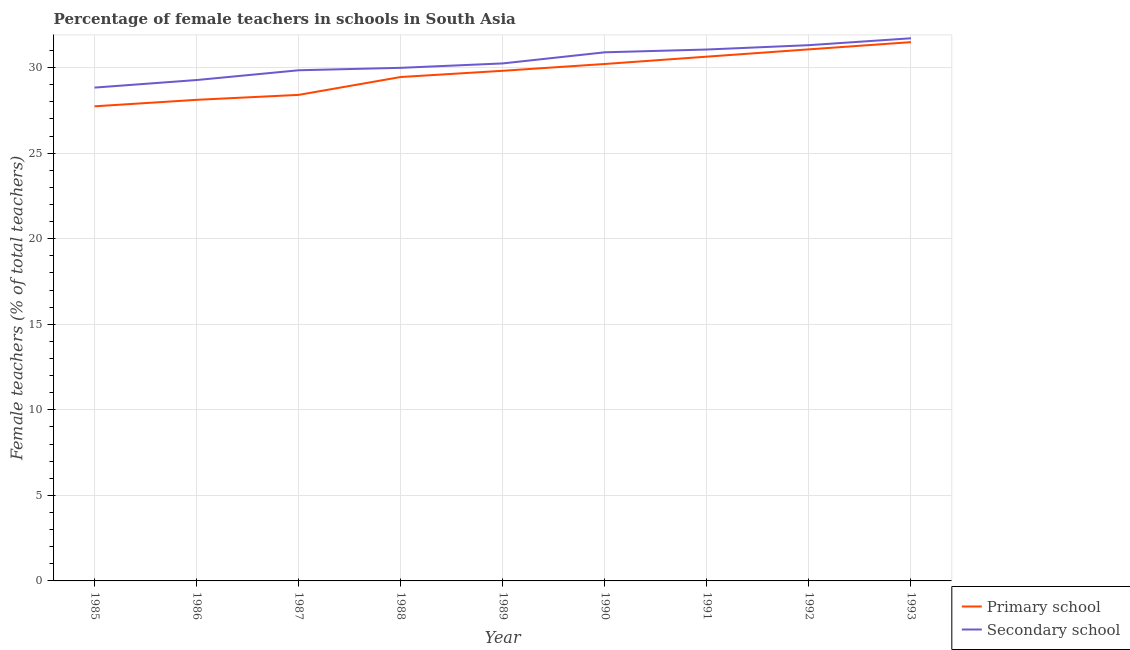How many different coloured lines are there?
Provide a short and direct response. 2. Is the number of lines equal to the number of legend labels?
Provide a short and direct response. Yes. What is the percentage of female teachers in secondary schools in 1990?
Your response must be concise. 30.89. Across all years, what is the maximum percentage of female teachers in primary schools?
Keep it short and to the point. 31.49. Across all years, what is the minimum percentage of female teachers in secondary schools?
Offer a terse response. 28.83. In which year was the percentage of female teachers in secondary schools maximum?
Provide a short and direct response. 1993. What is the total percentage of female teachers in secondary schools in the graph?
Give a very brief answer. 273.14. What is the difference between the percentage of female teachers in secondary schools in 1985 and that in 1992?
Provide a succinct answer. -2.48. What is the difference between the percentage of female teachers in secondary schools in 1985 and the percentage of female teachers in primary schools in 1986?
Make the answer very short. 0.71. What is the average percentage of female teachers in primary schools per year?
Provide a short and direct response. 29.66. In the year 1991, what is the difference between the percentage of female teachers in primary schools and percentage of female teachers in secondary schools?
Offer a very short reply. -0.42. What is the ratio of the percentage of female teachers in primary schools in 1987 to that in 1993?
Provide a short and direct response. 0.9. Is the difference between the percentage of female teachers in secondary schools in 1987 and 1991 greater than the difference between the percentage of female teachers in primary schools in 1987 and 1991?
Provide a short and direct response. Yes. What is the difference between the highest and the second highest percentage of female teachers in secondary schools?
Give a very brief answer. 0.4. What is the difference between the highest and the lowest percentage of female teachers in secondary schools?
Offer a terse response. 2.88. Does the percentage of female teachers in primary schools monotonically increase over the years?
Your answer should be very brief. Yes. Is the percentage of female teachers in secondary schools strictly less than the percentage of female teachers in primary schools over the years?
Your response must be concise. No. How many years are there in the graph?
Ensure brevity in your answer.  9. What is the difference between two consecutive major ticks on the Y-axis?
Give a very brief answer. 5. Are the values on the major ticks of Y-axis written in scientific E-notation?
Offer a very short reply. No. Where does the legend appear in the graph?
Provide a succinct answer. Bottom right. How many legend labels are there?
Ensure brevity in your answer.  2. How are the legend labels stacked?
Your response must be concise. Vertical. What is the title of the graph?
Provide a succinct answer. Percentage of female teachers in schools in South Asia. What is the label or title of the Y-axis?
Offer a terse response. Female teachers (% of total teachers). What is the Female teachers (% of total teachers) in Primary school in 1985?
Ensure brevity in your answer.  27.74. What is the Female teachers (% of total teachers) in Secondary school in 1985?
Give a very brief answer. 28.83. What is the Female teachers (% of total teachers) in Primary school in 1986?
Keep it short and to the point. 28.11. What is the Female teachers (% of total teachers) of Secondary school in 1986?
Make the answer very short. 29.27. What is the Female teachers (% of total teachers) of Primary school in 1987?
Offer a very short reply. 28.4. What is the Female teachers (% of total teachers) of Secondary school in 1987?
Your answer should be compact. 29.84. What is the Female teachers (% of total teachers) of Primary school in 1988?
Give a very brief answer. 29.45. What is the Female teachers (% of total teachers) in Secondary school in 1988?
Offer a terse response. 29.99. What is the Female teachers (% of total teachers) of Primary school in 1989?
Offer a terse response. 29.81. What is the Female teachers (% of total teachers) of Secondary school in 1989?
Ensure brevity in your answer.  30.24. What is the Female teachers (% of total teachers) of Primary school in 1990?
Offer a terse response. 30.21. What is the Female teachers (% of total teachers) of Secondary school in 1990?
Your answer should be compact. 30.89. What is the Female teachers (% of total teachers) of Primary school in 1991?
Provide a short and direct response. 30.64. What is the Female teachers (% of total teachers) in Secondary school in 1991?
Offer a terse response. 31.06. What is the Female teachers (% of total teachers) of Primary school in 1992?
Your response must be concise. 31.06. What is the Female teachers (% of total teachers) of Secondary school in 1992?
Offer a very short reply. 31.31. What is the Female teachers (% of total teachers) in Primary school in 1993?
Make the answer very short. 31.49. What is the Female teachers (% of total teachers) of Secondary school in 1993?
Offer a terse response. 31.71. Across all years, what is the maximum Female teachers (% of total teachers) in Primary school?
Your answer should be very brief. 31.49. Across all years, what is the maximum Female teachers (% of total teachers) of Secondary school?
Give a very brief answer. 31.71. Across all years, what is the minimum Female teachers (% of total teachers) of Primary school?
Ensure brevity in your answer.  27.74. Across all years, what is the minimum Female teachers (% of total teachers) of Secondary school?
Give a very brief answer. 28.83. What is the total Female teachers (% of total teachers) of Primary school in the graph?
Your answer should be compact. 266.91. What is the total Female teachers (% of total teachers) in Secondary school in the graph?
Your answer should be compact. 273.14. What is the difference between the Female teachers (% of total teachers) of Primary school in 1985 and that in 1986?
Keep it short and to the point. -0.38. What is the difference between the Female teachers (% of total teachers) in Secondary school in 1985 and that in 1986?
Ensure brevity in your answer.  -0.44. What is the difference between the Female teachers (% of total teachers) of Primary school in 1985 and that in 1987?
Your answer should be compact. -0.67. What is the difference between the Female teachers (% of total teachers) in Secondary school in 1985 and that in 1987?
Provide a succinct answer. -1.01. What is the difference between the Female teachers (% of total teachers) of Primary school in 1985 and that in 1988?
Ensure brevity in your answer.  -1.71. What is the difference between the Female teachers (% of total teachers) in Secondary school in 1985 and that in 1988?
Give a very brief answer. -1.16. What is the difference between the Female teachers (% of total teachers) in Primary school in 1985 and that in 1989?
Make the answer very short. -2.08. What is the difference between the Female teachers (% of total teachers) in Secondary school in 1985 and that in 1989?
Ensure brevity in your answer.  -1.41. What is the difference between the Female teachers (% of total teachers) of Primary school in 1985 and that in 1990?
Ensure brevity in your answer.  -2.47. What is the difference between the Female teachers (% of total teachers) in Secondary school in 1985 and that in 1990?
Offer a very short reply. -2.06. What is the difference between the Female teachers (% of total teachers) in Primary school in 1985 and that in 1991?
Provide a short and direct response. -2.9. What is the difference between the Female teachers (% of total teachers) in Secondary school in 1985 and that in 1991?
Make the answer very short. -2.23. What is the difference between the Female teachers (% of total teachers) in Primary school in 1985 and that in 1992?
Give a very brief answer. -3.33. What is the difference between the Female teachers (% of total teachers) in Secondary school in 1985 and that in 1992?
Ensure brevity in your answer.  -2.48. What is the difference between the Female teachers (% of total teachers) of Primary school in 1985 and that in 1993?
Your answer should be very brief. -3.75. What is the difference between the Female teachers (% of total teachers) of Secondary school in 1985 and that in 1993?
Offer a very short reply. -2.88. What is the difference between the Female teachers (% of total teachers) in Primary school in 1986 and that in 1987?
Offer a terse response. -0.29. What is the difference between the Female teachers (% of total teachers) in Secondary school in 1986 and that in 1987?
Ensure brevity in your answer.  -0.57. What is the difference between the Female teachers (% of total teachers) of Primary school in 1986 and that in 1988?
Your response must be concise. -1.33. What is the difference between the Female teachers (% of total teachers) in Secondary school in 1986 and that in 1988?
Provide a short and direct response. -0.71. What is the difference between the Female teachers (% of total teachers) of Primary school in 1986 and that in 1989?
Provide a succinct answer. -1.7. What is the difference between the Female teachers (% of total teachers) in Secondary school in 1986 and that in 1989?
Offer a terse response. -0.97. What is the difference between the Female teachers (% of total teachers) of Primary school in 1986 and that in 1990?
Ensure brevity in your answer.  -2.1. What is the difference between the Female teachers (% of total teachers) in Secondary school in 1986 and that in 1990?
Keep it short and to the point. -1.62. What is the difference between the Female teachers (% of total teachers) of Primary school in 1986 and that in 1991?
Offer a very short reply. -2.52. What is the difference between the Female teachers (% of total teachers) of Secondary school in 1986 and that in 1991?
Ensure brevity in your answer.  -1.78. What is the difference between the Female teachers (% of total teachers) in Primary school in 1986 and that in 1992?
Offer a terse response. -2.95. What is the difference between the Female teachers (% of total teachers) in Secondary school in 1986 and that in 1992?
Your answer should be very brief. -2.04. What is the difference between the Female teachers (% of total teachers) in Primary school in 1986 and that in 1993?
Keep it short and to the point. -3.37. What is the difference between the Female teachers (% of total teachers) in Secondary school in 1986 and that in 1993?
Make the answer very short. -2.44. What is the difference between the Female teachers (% of total teachers) of Primary school in 1987 and that in 1988?
Make the answer very short. -1.04. What is the difference between the Female teachers (% of total teachers) of Secondary school in 1987 and that in 1988?
Provide a short and direct response. -0.14. What is the difference between the Female teachers (% of total teachers) of Primary school in 1987 and that in 1989?
Make the answer very short. -1.41. What is the difference between the Female teachers (% of total teachers) of Secondary school in 1987 and that in 1989?
Make the answer very short. -0.4. What is the difference between the Female teachers (% of total teachers) of Primary school in 1987 and that in 1990?
Give a very brief answer. -1.81. What is the difference between the Female teachers (% of total teachers) in Secondary school in 1987 and that in 1990?
Make the answer very short. -1.05. What is the difference between the Female teachers (% of total teachers) in Primary school in 1987 and that in 1991?
Offer a terse response. -2.23. What is the difference between the Female teachers (% of total teachers) in Secondary school in 1987 and that in 1991?
Keep it short and to the point. -1.21. What is the difference between the Female teachers (% of total teachers) in Primary school in 1987 and that in 1992?
Give a very brief answer. -2.66. What is the difference between the Female teachers (% of total teachers) in Secondary school in 1987 and that in 1992?
Ensure brevity in your answer.  -1.47. What is the difference between the Female teachers (% of total teachers) of Primary school in 1987 and that in 1993?
Your response must be concise. -3.08. What is the difference between the Female teachers (% of total teachers) of Secondary school in 1987 and that in 1993?
Provide a short and direct response. -1.87. What is the difference between the Female teachers (% of total teachers) of Primary school in 1988 and that in 1989?
Provide a short and direct response. -0.36. What is the difference between the Female teachers (% of total teachers) of Secondary school in 1988 and that in 1989?
Offer a terse response. -0.26. What is the difference between the Female teachers (% of total teachers) in Primary school in 1988 and that in 1990?
Your answer should be very brief. -0.76. What is the difference between the Female teachers (% of total teachers) in Secondary school in 1988 and that in 1990?
Give a very brief answer. -0.91. What is the difference between the Female teachers (% of total teachers) of Primary school in 1988 and that in 1991?
Give a very brief answer. -1.19. What is the difference between the Female teachers (% of total teachers) in Secondary school in 1988 and that in 1991?
Your response must be concise. -1.07. What is the difference between the Female teachers (% of total teachers) of Primary school in 1988 and that in 1992?
Ensure brevity in your answer.  -1.62. What is the difference between the Female teachers (% of total teachers) in Secondary school in 1988 and that in 1992?
Provide a short and direct response. -1.32. What is the difference between the Female teachers (% of total teachers) in Primary school in 1988 and that in 1993?
Ensure brevity in your answer.  -2.04. What is the difference between the Female teachers (% of total teachers) in Secondary school in 1988 and that in 1993?
Give a very brief answer. -1.73. What is the difference between the Female teachers (% of total teachers) of Primary school in 1989 and that in 1990?
Make the answer very short. -0.4. What is the difference between the Female teachers (% of total teachers) of Secondary school in 1989 and that in 1990?
Provide a succinct answer. -0.65. What is the difference between the Female teachers (% of total teachers) of Primary school in 1989 and that in 1991?
Your response must be concise. -0.83. What is the difference between the Female teachers (% of total teachers) in Secondary school in 1989 and that in 1991?
Make the answer very short. -0.81. What is the difference between the Female teachers (% of total teachers) in Primary school in 1989 and that in 1992?
Your answer should be very brief. -1.25. What is the difference between the Female teachers (% of total teachers) of Secondary school in 1989 and that in 1992?
Keep it short and to the point. -1.07. What is the difference between the Female teachers (% of total teachers) of Primary school in 1989 and that in 1993?
Ensure brevity in your answer.  -1.67. What is the difference between the Female teachers (% of total teachers) of Secondary school in 1989 and that in 1993?
Offer a very short reply. -1.47. What is the difference between the Female teachers (% of total teachers) in Primary school in 1990 and that in 1991?
Make the answer very short. -0.43. What is the difference between the Female teachers (% of total teachers) in Secondary school in 1990 and that in 1991?
Your answer should be very brief. -0.16. What is the difference between the Female teachers (% of total teachers) of Primary school in 1990 and that in 1992?
Offer a very short reply. -0.85. What is the difference between the Female teachers (% of total teachers) of Secondary school in 1990 and that in 1992?
Offer a very short reply. -0.42. What is the difference between the Female teachers (% of total teachers) in Primary school in 1990 and that in 1993?
Ensure brevity in your answer.  -1.28. What is the difference between the Female teachers (% of total teachers) in Secondary school in 1990 and that in 1993?
Give a very brief answer. -0.82. What is the difference between the Female teachers (% of total teachers) of Primary school in 1991 and that in 1992?
Make the answer very short. -0.43. What is the difference between the Female teachers (% of total teachers) in Secondary school in 1991 and that in 1992?
Offer a very short reply. -0.25. What is the difference between the Female teachers (% of total teachers) of Primary school in 1991 and that in 1993?
Your response must be concise. -0.85. What is the difference between the Female teachers (% of total teachers) in Secondary school in 1991 and that in 1993?
Ensure brevity in your answer.  -0.66. What is the difference between the Female teachers (% of total teachers) in Primary school in 1992 and that in 1993?
Give a very brief answer. -0.42. What is the difference between the Female teachers (% of total teachers) in Secondary school in 1992 and that in 1993?
Ensure brevity in your answer.  -0.4. What is the difference between the Female teachers (% of total teachers) in Primary school in 1985 and the Female teachers (% of total teachers) in Secondary school in 1986?
Keep it short and to the point. -1.54. What is the difference between the Female teachers (% of total teachers) in Primary school in 1985 and the Female teachers (% of total teachers) in Secondary school in 1987?
Your answer should be very brief. -2.11. What is the difference between the Female teachers (% of total teachers) in Primary school in 1985 and the Female teachers (% of total teachers) in Secondary school in 1988?
Offer a terse response. -2.25. What is the difference between the Female teachers (% of total teachers) of Primary school in 1985 and the Female teachers (% of total teachers) of Secondary school in 1989?
Provide a short and direct response. -2.51. What is the difference between the Female teachers (% of total teachers) in Primary school in 1985 and the Female teachers (% of total teachers) in Secondary school in 1990?
Your answer should be compact. -3.16. What is the difference between the Female teachers (% of total teachers) of Primary school in 1985 and the Female teachers (% of total teachers) of Secondary school in 1991?
Offer a terse response. -3.32. What is the difference between the Female teachers (% of total teachers) in Primary school in 1985 and the Female teachers (% of total teachers) in Secondary school in 1992?
Your response must be concise. -3.57. What is the difference between the Female teachers (% of total teachers) of Primary school in 1985 and the Female teachers (% of total teachers) of Secondary school in 1993?
Offer a very short reply. -3.98. What is the difference between the Female teachers (% of total teachers) of Primary school in 1986 and the Female teachers (% of total teachers) of Secondary school in 1987?
Offer a very short reply. -1.73. What is the difference between the Female teachers (% of total teachers) in Primary school in 1986 and the Female teachers (% of total teachers) in Secondary school in 1988?
Ensure brevity in your answer.  -1.87. What is the difference between the Female teachers (% of total teachers) in Primary school in 1986 and the Female teachers (% of total teachers) in Secondary school in 1989?
Offer a very short reply. -2.13. What is the difference between the Female teachers (% of total teachers) in Primary school in 1986 and the Female teachers (% of total teachers) in Secondary school in 1990?
Your answer should be compact. -2.78. What is the difference between the Female teachers (% of total teachers) in Primary school in 1986 and the Female teachers (% of total teachers) in Secondary school in 1991?
Provide a short and direct response. -2.94. What is the difference between the Female teachers (% of total teachers) in Primary school in 1986 and the Female teachers (% of total teachers) in Secondary school in 1992?
Your answer should be very brief. -3.19. What is the difference between the Female teachers (% of total teachers) of Primary school in 1986 and the Female teachers (% of total teachers) of Secondary school in 1993?
Your answer should be compact. -3.6. What is the difference between the Female teachers (% of total teachers) of Primary school in 1987 and the Female teachers (% of total teachers) of Secondary school in 1988?
Your response must be concise. -1.58. What is the difference between the Female teachers (% of total teachers) of Primary school in 1987 and the Female teachers (% of total teachers) of Secondary school in 1989?
Give a very brief answer. -1.84. What is the difference between the Female teachers (% of total teachers) of Primary school in 1987 and the Female teachers (% of total teachers) of Secondary school in 1990?
Your answer should be very brief. -2.49. What is the difference between the Female teachers (% of total teachers) of Primary school in 1987 and the Female teachers (% of total teachers) of Secondary school in 1991?
Offer a very short reply. -2.65. What is the difference between the Female teachers (% of total teachers) of Primary school in 1987 and the Female teachers (% of total teachers) of Secondary school in 1992?
Make the answer very short. -2.91. What is the difference between the Female teachers (% of total teachers) in Primary school in 1987 and the Female teachers (% of total teachers) in Secondary school in 1993?
Offer a very short reply. -3.31. What is the difference between the Female teachers (% of total teachers) in Primary school in 1988 and the Female teachers (% of total teachers) in Secondary school in 1989?
Ensure brevity in your answer.  -0.79. What is the difference between the Female teachers (% of total teachers) of Primary school in 1988 and the Female teachers (% of total teachers) of Secondary school in 1990?
Give a very brief answer. -1.44. What is the difference between the Female teachers (% of total teachers) of Primary school in 1988 and the Female teachers (% of total teachers) of Secondary school in 1991?
Your answer should be compact. -1.61. What is the difference between the Female teachers (% of total teachers) of Primary school in 1988 and the Female teachers (% of total teachers) of Secondary school in 1992?
Your answer should be very brief. -1.86. What is the difference between the Female teachers (% of total teachers) of Primary school in 1988 and the Female teachers (% of total teachers) of Secondary school in 1993?
Make the answer very short. -2.26. What is the difference between the Female teachers (% of total teachers) in Primary school in 1989 and the Female teachers (% of total teachers) in Secondary school in 1990?
Your answer should be compact. -1.08. What is the difference between the Female teachers (% of total teachers) in Primary school in 1989 and the Female teachers (% of total teachers) in Secondary school in 1991?
Keep it short and to the point. -1.24. What is the difference between the Female teachers (% of total teachers) in Primary school in 1989 and the Female teachers (% of total teachers) in Secondary school in 1992?
Offer a terse response. -1.5. What is the difference between the Female teachers (% of total teachers) of Primary school in 1990 and the Female teachers (% of total teachers) of Secondary school in 1991?
Provide a succinct answer. -0.85. What is the difference between the Female teachers (% of total teachers) of Primary school in 1990 and the Female teachers (% of total teachers) of Secondary school in 1992?
Offer a terse response. -1.1. What is the difference between the Female teachers (% of total teachers) of Primary school in 1990 and the Female teachers (% of total teachers) of Secondary school in 1993?
Offer a terse response. -1.5. What is the difference between the Female teachers (% of total teachers) in Primary school in 1991 and the Female teachers (% of total teachers) in Secondary school in 1992?
Offer a terse response. -0.67. What is the difference between the Female teachers (% of total teachers) of Primary school in 1991 and the Female teachers (% of total teachers) of Secondary school in 1993?
Keep it short and to the point. -1.07. What is the difference between the Female teachers (% of total teachers) in Primary school in 1992 and the Female teachers (% of total teachers) in Secondary school in 1993?
Keep it short and to the point. -0.65. What is the average Female teachers (% of total teachers) in Primary school per year?
Provide a succinct answer. 29.66. What is the average Female teachers (% of total teachers) in Secondary school per year?
Give a very brief answer. 30.35. In the year 1985, what is the difference between the Female teachers (% of total teachers) in Primary school and Female teachers (% of total teachers) in Secondary school?
Make the answer very short. -1.09. In the year 1986, what is the difference between the Female teachers (% of total teachers) in Primary school and Female teachers (% of total teachers) in Secondary school?
Offer a terse response. -1.16. In the year 1987, what is the difference between the Female teachers (% of total teachers) in Primary school and Female teachers (% of total teachers) in Secondary school?
Offer a very short reply. -1.44. In the year 1988, what is the difference between the Female teachers (% of total teachers) in Primary school and Female teachers (% of total teachers) in Secondary school?
Keep it short and to the point. -0.54. In the year 1989, what is the difference between the Female teachers (% of total teachers) in Primary school and Female teachers (% of total teachers) in Secondary school?
Make the answer very short. -0.43. In the year 1990, what is the difference between the Female teachers (% of total teachers) of Primary school and Female teachers (% of total teachers) of Secondary school?
Make the answer very short. -0.68. In the year 1991, what is the difference between the Female teachers (% of total teachers) in Primary school and Female teachers (% of total teachers) in Secondary school?
Offer a terse response. -0.42. In the year 1992, what is the difference between the Female teachers (% of total teachers) in Primary school and Female teachers (% of total teachers) in Secondary school?
Keep it short and to the point. -0.25. In the year 1993, what is the difference between the Female teachers (% of total teachers) in Primary school and Female teachers (% of total teachers) in Secondary school?
Give a very brief answer. -0.23. What is the ratio of the Female teachers (% of total teachers) in Primary school in 1985 to that in 1986?
Your answer should be compact. 0.99. What is the ratio of the Female teachers (% of total teachers) in Secondary school in 1985 to that in 1986?
Offer a terse response. 0.98. What is the ratio of the Female teachers (% of total teachers) in Primary school in 1985 to that in 1987?
Your answer should be very brief. 0.98. What is the ratio of the Female teachers (% of total teachers) in Secondary school in 1985 to that in 1987?
Ensure brevity in your answer.  0.97. What is the ratio of the Female teachers (% of total teachers) of Primary school in 1985 to that in 1988?
Give a very brief answer. 0.94. What is the ratio of the Female teachers (% of total teachers) in Secondary school in 1985 to that in 1988?
Give a very brief answer. 0.96. What is the ratio of the Female teachers (% of total teachers) of Primary school in 1985 to that in 1989?
Your answer should be very brief. 0.93. What is the ratio of the Female teachers (% of total teachers) of Secondary school in 1985 to that in 1989?
Provide a succinct answer. 0.95. What is the ratio of the Female teachers (% of total teachers) of Primary school in 1985 to that in 1990?
Give a very brief answer. 0.92. What is the ratio of the Female teachers (% of total teachers) in Secondary school in 1985 to that in 1990?
Your answer should be compact. 0.93. What is the ratio of the Female teachers (% of total teachers) in Primary school in 1985 to that in 1991?
Offer a very short reply. 0.91. What is the ratio of the Female teachers (% of total teachers) of Secondary school in 1985 to that in 1991?
Provide a short and direct response. 0.93. What is the ratio of the Female teachers (% of total teachers) of Primary school in 1985 to that in 1992?
Give a very brief answer. 0.89. What is the ratio of the Female teachers (% of total teachers) in Secondary school in 1985 to that in 1992?
Your answer should be compact. 0.92. What is the ratio of the Female teachers (% of total teachers) of Primary school in 1985 to that in 1993?
Ensure brevity in your answer.  0.88. What is the ratio of the Female teachers (% of total teachers) in Secondary school in 1985 to that in 1993?
Offer a very short reply. 0.91. What is the ratio of the Female teachers (% of total teachers) in Secondary school in 1986 to that in 1987?
Provide a short and direct response. 0.98. What is the ratio of the Female teachers (% of total teachers) in Primary school in 1986 to that in 1988?
Ensure brevity in your answer.  0.95. What is the ratio of the Female teachers (% of total teachers) of Secondary school in 1986 to that in 1988?
Keep it short and to the point. 0.98. What is the ratio of the Female teachers (% of total teachers) in Primary school in 1986 to that in 1989?
Offer a very short reply. 0.94. What is the ratio of the Female teachers (% of total teachers) of Secondary school in 1986 to that in 1989?
Make the answer very short. 0.97. What is the ratio of the Female teachers (% of total teachers) of Primary school in 1986 to that in 1990?
Keep it short and to the point. 0.93. What is the ratio of the Female teachers (% of total teachers) in Secondary school in 1986 to that in 1990?
Offer a very short reply. 0.95. What is the ratio of the Female teachers (% of total teachers) in Primary school in 1986 to that in 1991?
Offer a very short reply. 0.92. What is the ratio of the Female teachers (% of total teachers) in Secondary school in 1986 to that in 1991?
Provide a succinct answer. 0.94. What is the ratio of the Female teachers (% of total teachers) of Primary school in 1986 to that in 1992?
Your answer should be very brief. 0.91. What is the ratio of the Female teachers (% of total teachers) of Secondary school in 1986 to that in 1992?
Offer a terse response. 0.93. What is the ratio of the Female teachers (% of total teachers) in Primary school in 1986 to that in 1993?
Keep it short and to the point. 0.89. What is the ratio of the Female teachers (% of total teachers) in Secondary school in 1986 to that in 1993?
Your answer should be compact. 0.92. What is the ratio of the Female teachers (% of total teachers) in Primary school in 1987 to that in 1988?
Provide a short and direct response. 0.96. What is the ratio of the Female teachers (% of total teachers) of Secondary school in 1987 to that in 1988?
Provide a succinct answer. 1. What is the ratio of the Female teachers (% of total teachers) of Primary school in 1987 to that in 1989?
Offer a very short reply. 0.95. What is the ratio of the Female teachers (% of total teachers) of Secondary school in 1987 to that in 1989?
Provide a short and direct response. 0.99. What is the ratio of the Female teachers (% of total teachers) of Primary school in 1987 to that in 1990?
Your answer should be very brief. 0.94. What is the ratio of the Female teachers (% of total teachers) of Secondary school in 1987 to that in 1990?
Make the answer very short. 0.97. What is the ratio of the Female teachers (% of total teachers) of Primary school in 1987 to that in 1991?
Make the answer very short. 0.93. What is the ratio of the Female teachers (% of total teachers) in Secondary school in 1987 to that in 1991?
Provide a short and direct response. 0.96. What is the ratio of the Female teachers (% of total teachers) in Primary school in 1987 to that in 1992?
Provide a succinct answer. 0.91. What is the ratio of the Female teachers (% of total teachers) of Secondary school in 1987 to that in 1992?
Give a very brief answer. 0.95. What is the ratio of the Female teachers (% of total teachers) of Primary school in 1987 to that in 1993?
Offer a terse response. 0.9. What is the ratio of the Female teachers (% of total teachers) in Secondary school in 1987 to that in 1993?
Provide a succinct answer. 0.94. What is the ratio of the Female teachers (% of total teachers) in Primary school in 1988 to that in 1989?
Give a very brief answer. 0.99. What is the ratio of the Female teachers (% of total teachers) in Secondary school in 1988 to that in 1989?
Keep it short and to the point. 0.99. What is the ratio of the Female teachers (% of total teachers) of Primary school in 1988 to that in 1990?
Offer a terse response. 0.97. What is the ratio of the Female teachers (% of total teachers) in Secondary school in 1988 to that in 1990?
Offer a terse response. 0.97. What is the ratio of the Female teachers (% of total teachers) of Primary school in 1988 to that in 1991?
Provide a succinct answer. 0.96. What is the ratio of the Female teachers (% of total teachers) of Secondary school in 1988 to that in 1991?
Offer a very short reply. 0.97. What is the ratio of the Female teachers (% of total teachers) of Primary school in 1988 to that in 1992?
Provide a succinct answer. 0.95. What is the ratio of the Female teachers (% of total teachers) in Secondary school in 1988 to that in 1992?
Provide a succinct answer. 0.96. What is the ratio of the Female teachers (% of total teachers) of Primary school in 1988 to that in 1993?
Provide a succinct answer. 0.94. What is the ratio of the Female teachers (% of total teachers) in Secondary school in 1988 to that in 1993?
Your response must be concise. 0.95. What is the ratio of the Female teachers (% of total teachers) in Secondary school in 1989 to that in 1990?
Offer a very short reply. 0.98. What is the ratio of the Female teachers (% of total teachers) in Secondary school in 1989 to that in 1991?
Your response must be concise. 0.97. What is the ratio of the Female teachers (% of total teachers) of Primary school in 1989 to that in 1992?
Make the answer very short. 0.96. What is the ratio of the Female teachers (% of total teachers) of Secondary school in 1989 to that in 1992?
Ensure brevity in your answer.  0.97. What is the ratio of the Female teachers (% of total teachers) of Primary school in 1989 to that in 1993?
Your response must be concise. 0.95. What is the ratio of the Female teachers (% of total teachers) in Secondary school in 1989 to that in 1993?
Ensure brevity in your answer.  0.95. What is the ratio of the Female teachers (% of total teachers) of Primary school in 1990 to that in 1992?
Your answer should be compact. 0.97. What is the ratio of the Female teachers (% of total teachers) in Secondary school in 1990 to that in 1992?
Your answer should be very brief. 0.99. What is the ratio of the Female teachers (% of total teachers) in Primary school in 1990 to that in 1993?
Provide a succinct answer. 0.96. What is the ratio of the Female teachers (% of total teachers) of Secondary school in 1990 to that in 1993?
Your answer should be compact. 0.97. What is the ratio of the Female teachers (% of total teachers) of Primary school in 1991 to that in 1992?
Your response must be concise. 0.99. What is the ratio of the Female teachers (% of total teachers) of Primary school in 1991 to that in 1993?
Ensure brevity in your answer.  0.97. What is the ratio of the Female teachers (% of total teachers) in Secondary school in 1991 to that in 1993?
Provide a succinct answer. 0.98. What is the ratio of the Female teachers (% of total teachers) in Primary school in 1992 to that in 1993?
Provide a succinct answer. 0.99. What is the ratio of the Female teachers (% of total teachers) of Secondary school in 1992 to that in 1993?
Keep it short and to the point. 0.99. What is the difference between the highest and the second highest Female teachers (% of total teachers) in Primary school?
Provide a succinct answer. 0.42. What is the difference between the highest and the second highest Female teachers (% of total teachers) in Secondary school?
Ensure brevity in your answer.  0.4. What is the difference between the highest and the lowest Female teachers (% of total teachers) of Primary school?
Your response must be concise. 3.75. What is the difference between the highest and the lowest Female teachers (% of total teachers) of Secondary school?
Ensure brevity in your answer.  2.88. 